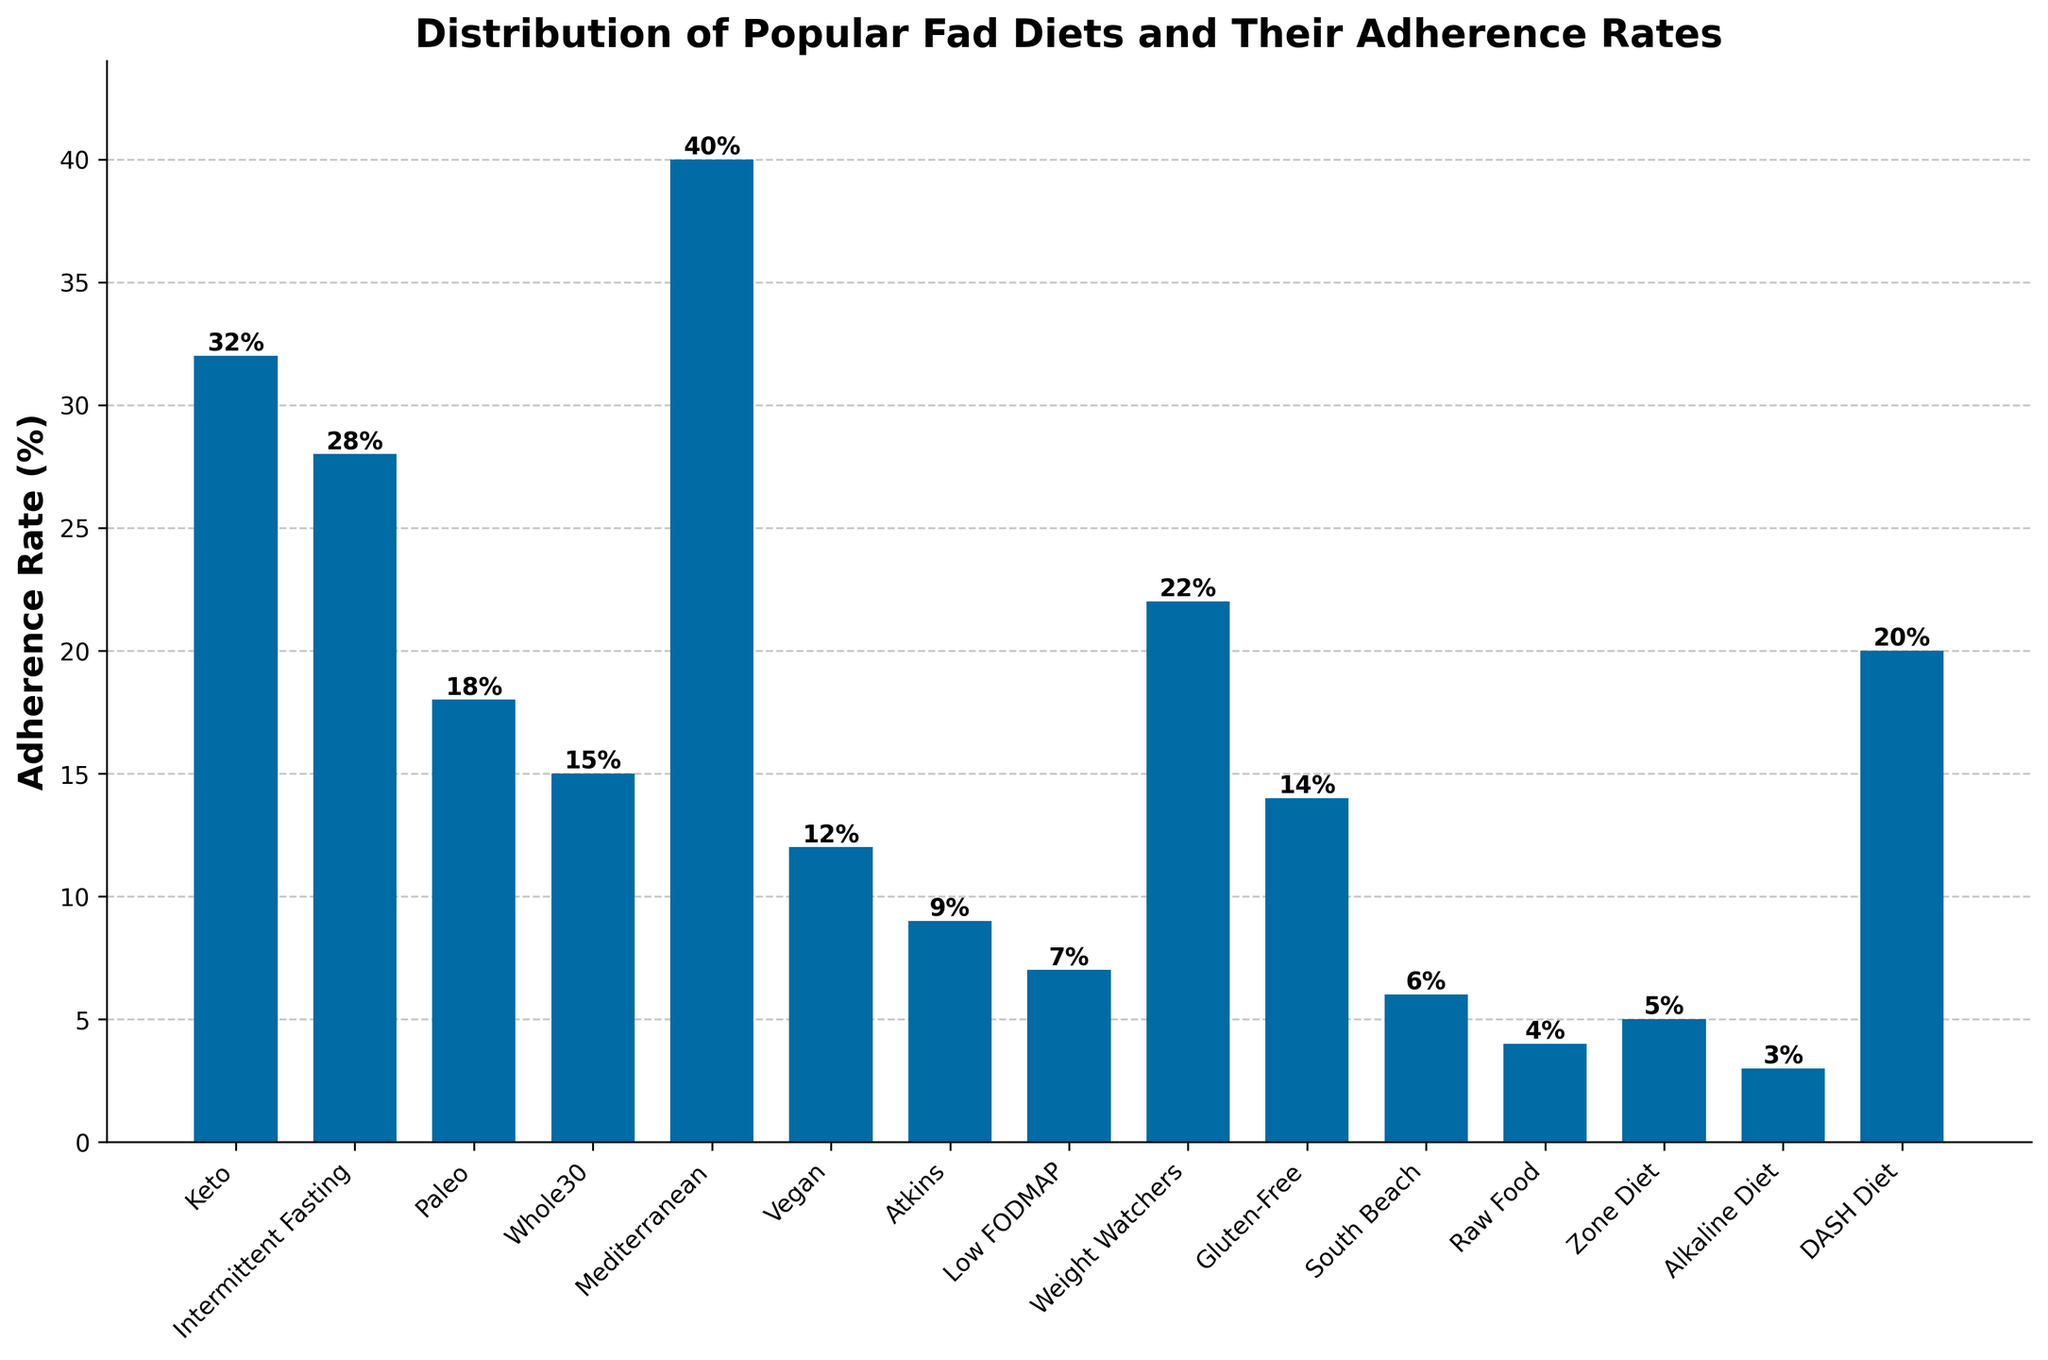what diet has the highest adherence rate? From the figure, the tallest bar indicates the highest adherence rate, which is for the Mediterranean diet with an adherence rate of 40%.
Answer: Mediterranean diet Which diet has the lowest adherence rate? The shortest bar on the chart represents the diet with the lowest adherence rate, which is the Alkaline Diet with a rate of 3%.
Answer: Alkaline Diet What is the difference in adherence rates between the Keto and Paleo diets? The bar for the Keto diet shows an adherence rate of 32%, and the bar for the Paleo diet shows 18%. The difference is calculated as 32% - 18% = 14%.
Answer: 14% Which diets have adherence rates higher than 20%? The bars that reach above the 20% mark represent the diets with higher adherence rates. These diets are Mediterranean (40%), Keto (32%), Intermittent Fasting (28%), Weight Watchers (22%), and DASH Diet (20%).
Answer: Mediterranean, Keto, Intermittent Fasting, Weight Watchers, DASH Diet How many diets have adherence rates lower than 10%? Counting the bars that fall below the 10% mark: Atkins (9%), Low FODMAP (7%), South Beach (6%), Zone Diet (5%), Raw Food (4%), and Alkaline Diet (3%). There are 6 diets in total.
Answer: 6 What is the combined adherence rate of Whole30, Vegan, and Gluten-Free diets? The bars for these diets show adherence rates of 15% (Whole30), 12% (Vegan), and 14% (Gluten-Free). Adding these together: 15% + 12% + 14% = 41%.
Answer: 41% What are the median adherence rates of all diets? To find the median, list all adherence rates in ascending order: 3, 4, 5, 6, 7, 9, 12, 14, 15, 18, 20, 22, 28, 32, 40. With 15 data points, the median is the 8th value: 14%.
Answer: 14% Which diet's adherence rate is closest to the adherence rate of the DASH Diet? The adherence rate of the DASH Diet is 20%. The rates that are nearest to 20% are Whole30 (15%) and Weight Watchers (22%). Among these, Weight Watchers has the closest adherence rate.
Answer: Weight Watchers 